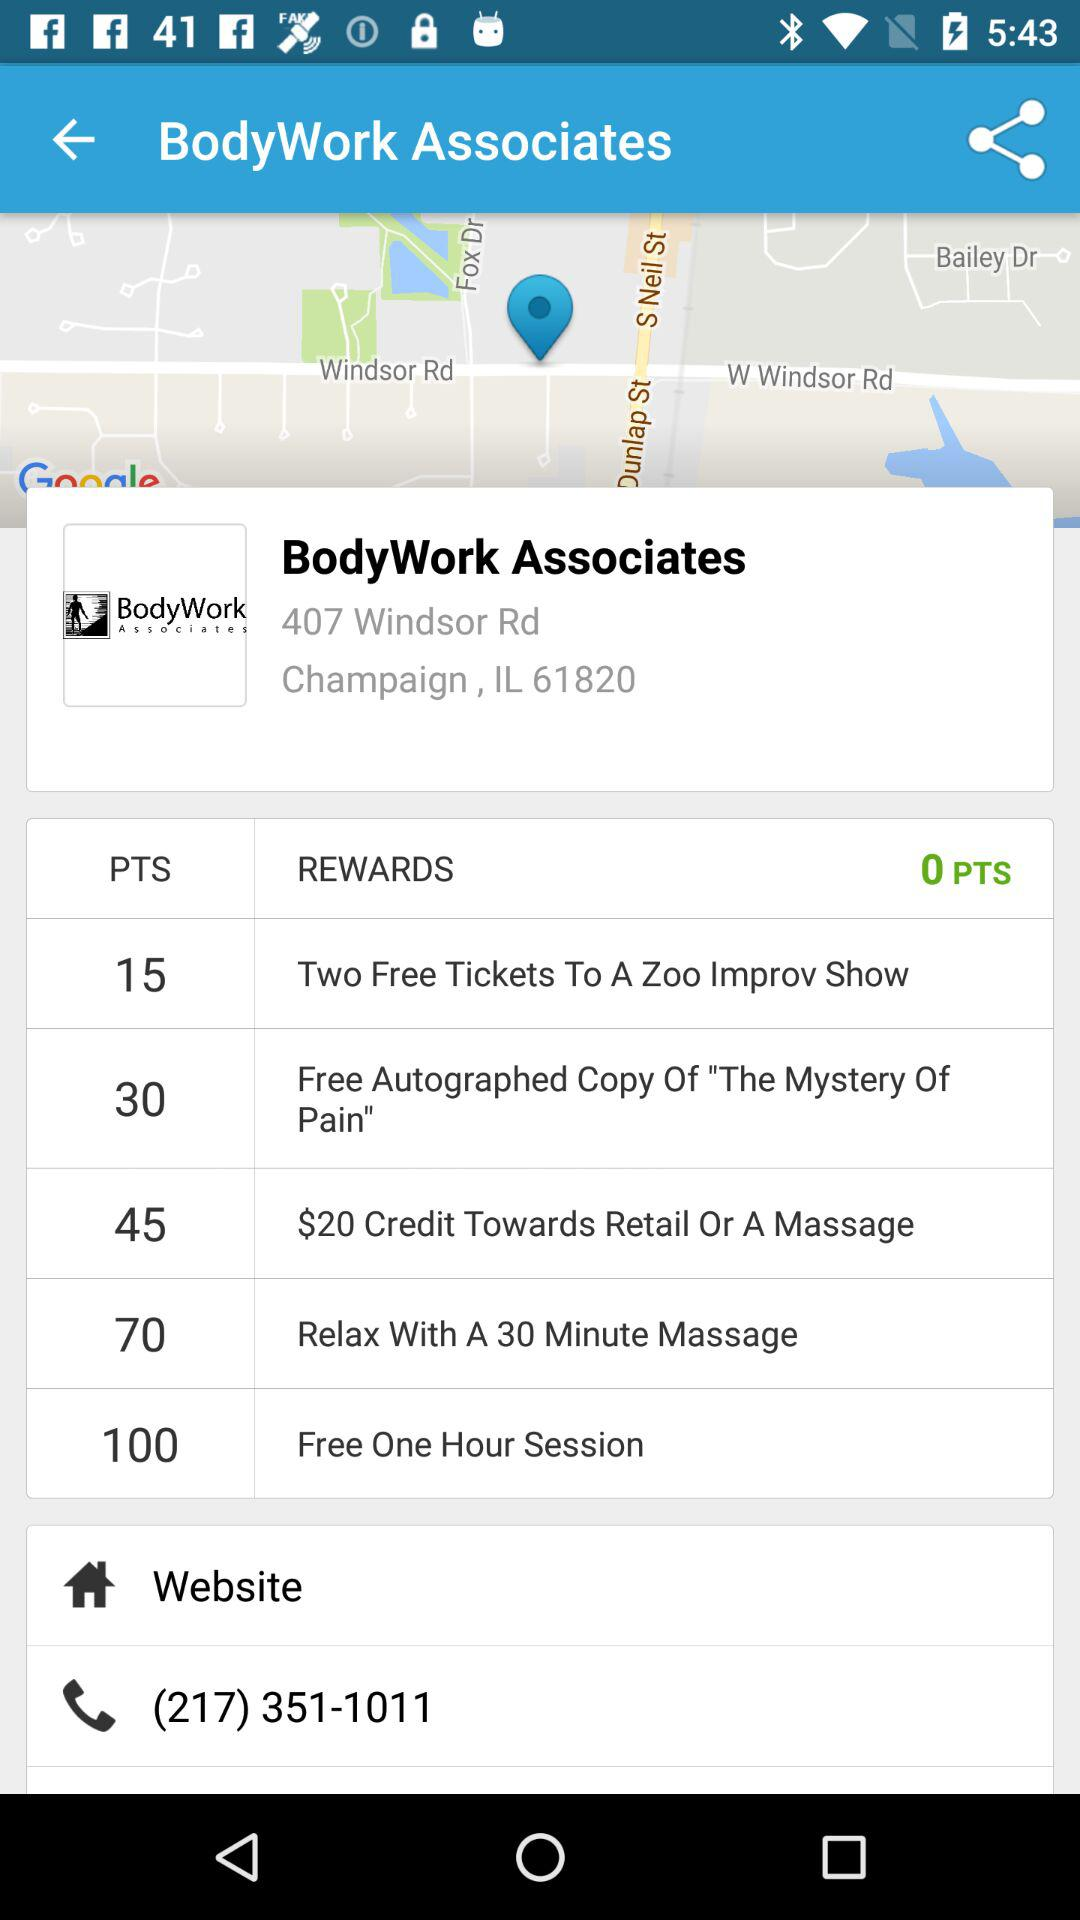What is the contact number? The contact number is (217) 351-1011. 